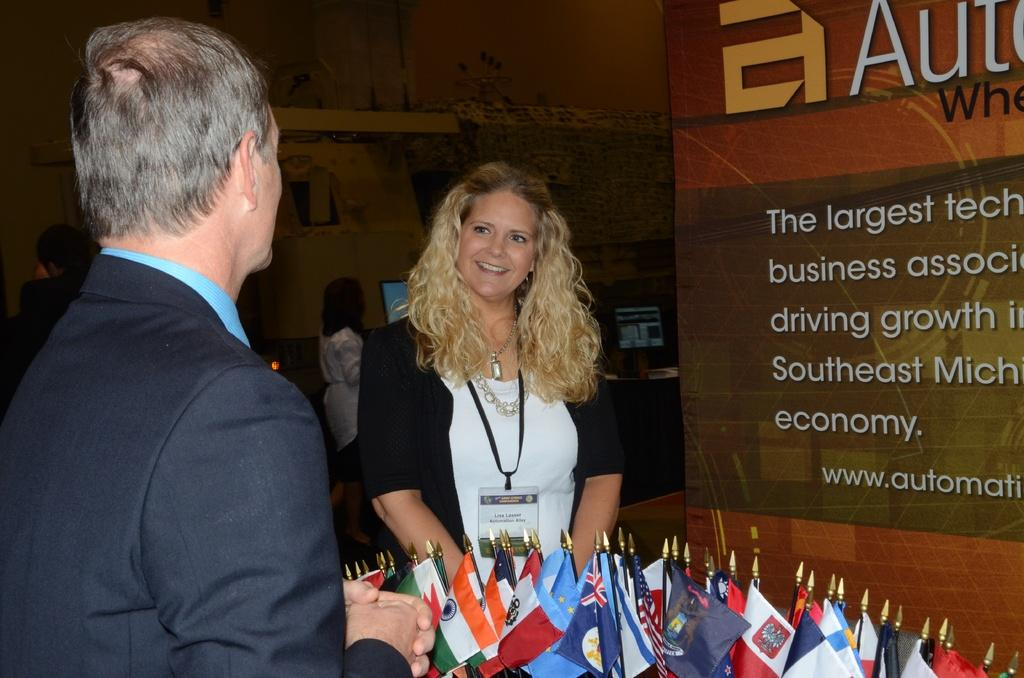Who is the main subject in the image? There is a lady in the center of the image. What is the lady wearing? The lady is wearing an ID card. What expression does the lady have? The lady is smiling. What can be seen in the background of the image? There are other people, monitors, flags, and boards visible in the background of the image. What type of cherry is the lady holding in the image? There is no cherry present in the image; the lady is wearing an ID card and there are no fruits visible. 